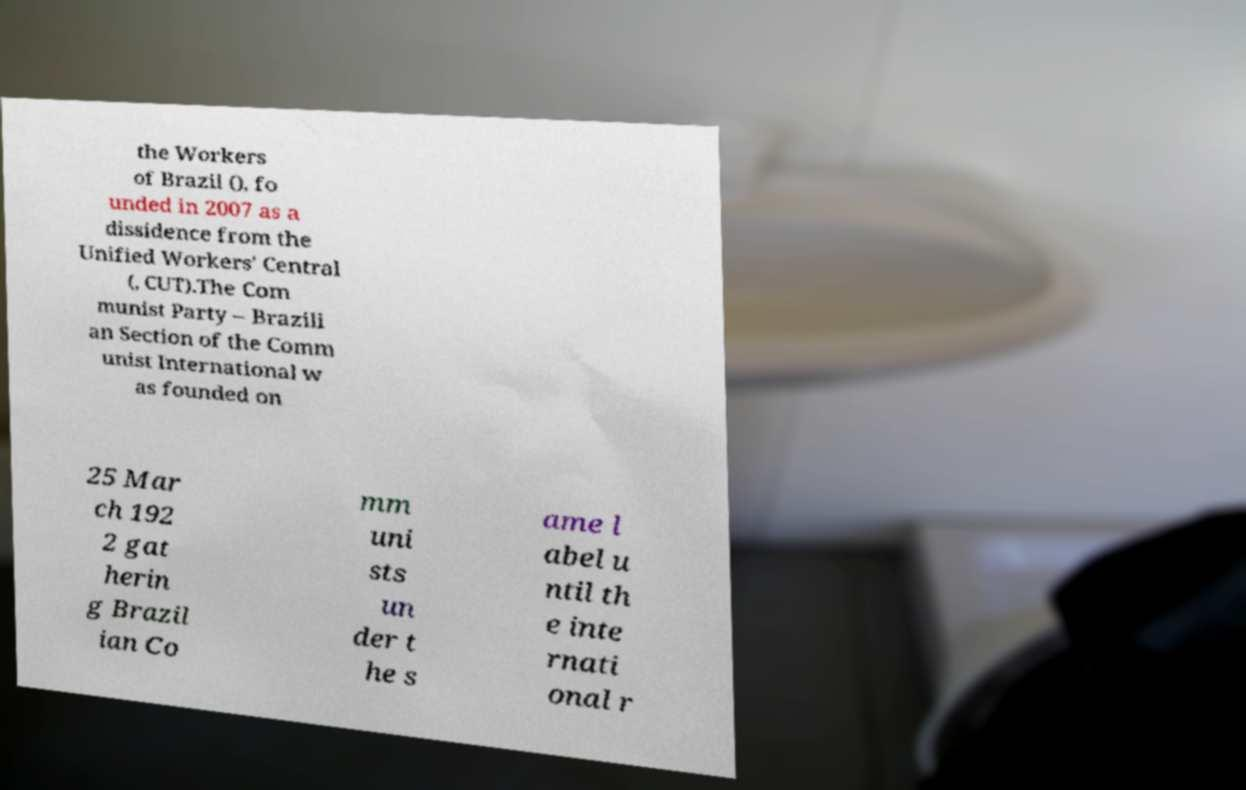Please identify and transcribe the text found in this image. the Workers of Brazil (), fo unded in 2007 as a dissidence from the Unified Workers' Central (, CUT).The Com munist Party – Brazili an Section of the Comm unist International w as founded on 25 Mar ch 192 2 gat herin g Brazil ian Co mm uni sts un der t he s ame l abel u ntil th e inte rnati onal r 